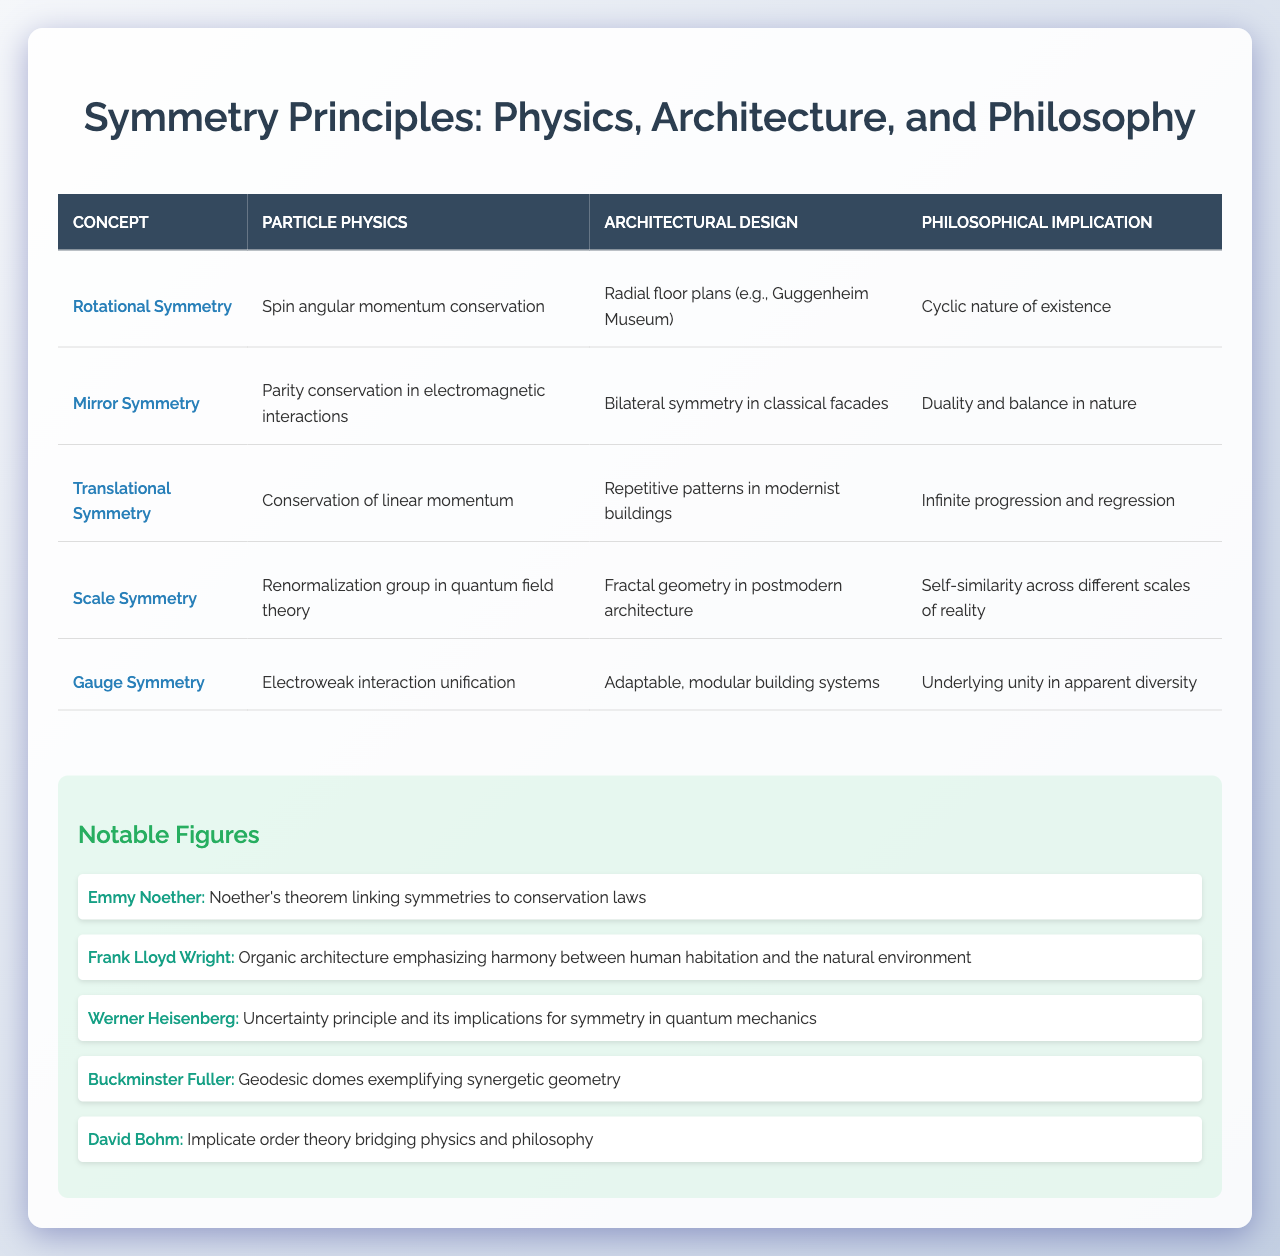What is the philosophical implication of "Translational Symmetry"? The philosophical implication of Translational Symmetry, as mentioned in the table, is "Infinite progression and regression." This is directly retrieved from the respective row in the table.
Answer: Infinite progression and regression Which architectural design illustrates "Mirror Symmetry"? The architectural design illustrating Mirror Symmetry is "Bilateral symmetry in classical facades." This detail can be found in the second row under the architectural design column.
Answer: Bilateral symmetry in classical facades What type of symmetry is associated with conservation of linear momentum? The type of symmetry associated with conservation of linear momentum is "Translational Symmetry." This is evident from the table where it aligns with the conservation fact in particle physics.
Answer: Translational Symmetry Who contributed to the concept of self-similarity in architecture? The contribution to the concept of self-similarity in architecture is from "Buckminster Fuller," who focused on geodesic domes, as listed in the notable figures section.
Answer: Buckminster Fuller Which concept connects to both conservation laws in physics and philosophical notions of duality? The concept that connects both is "Mirror Symmetry." The table indicates that it relates to parity conservation in physics and embodies duality in philosophy.
Answer: Mirror Symmetry Which symmetry principles share the same philosophical implication of "Underlying unity in apparent diversity"? The symmetry principle that shares this philosophical implication is "Gauge Symmetry." The explanation comes from the table where it states the implication clearly.
Answer: Gauge Symmetry What is the relationship between rotational symmetry and architectural designs like the Guggenheim Museum? The relationship is that Rotational Symmetry is exemplified in radial floor plans, such as that of the Guggenheim Museum, as stated in the table.
Answer: Radial floor plans How many symmetry principles are listed in the table? There are five symmetry principles listed in the table. This can be verified by counting the entries under the concepts section.
Answer: Five What symmetry principle is characterized by "Fractal geometry in postmodern architecture"? The symmetry principle characterized by "Fractal geometry in postmodern architecture" is "Scale Symmetry," as directly stated in the appropriate row of the table.
Answer: Scale Symmetry True or False: Gauge Symmetry relates to adaptative architectural designs. True, according to the table, Gauge Symmetry relates to adaptable, modular building systems in architectural design.
Answer: True What does "Cyclic nature of existence" imply regarding the concept of Rotational Symmetry? The implication is that Rotational Symmetry ties back to philosophical ideas about continuity and recurrence. This can be inferred from the provided philosophical implication related to Rotational Symmetry in the table.
Answer: Continuity and recurrence 